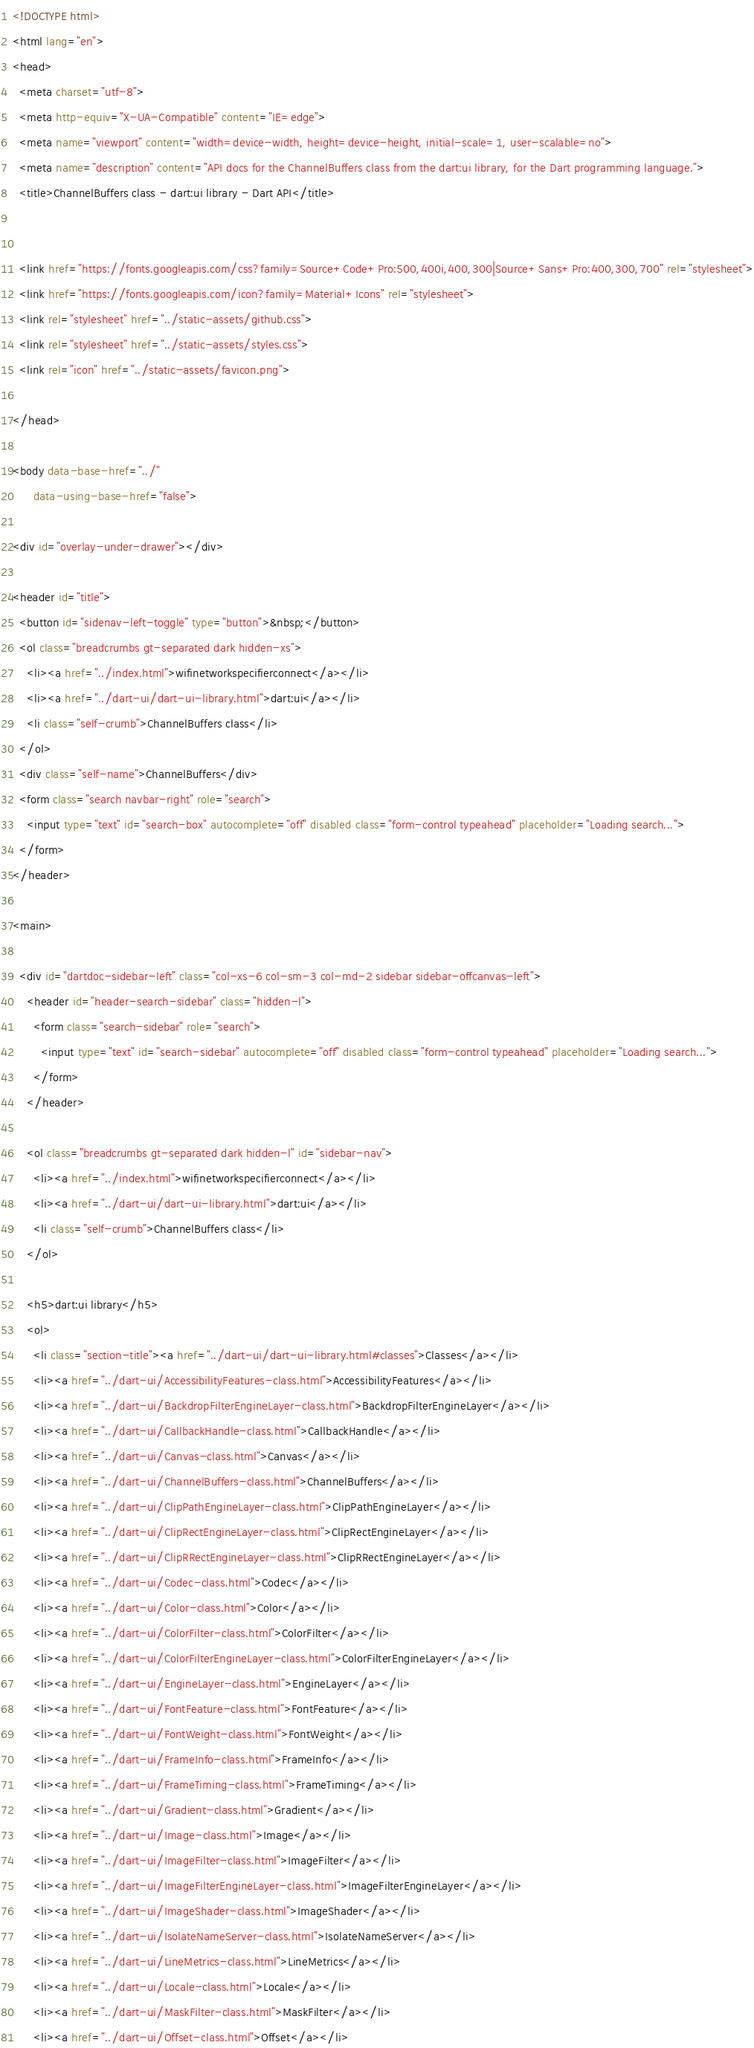Convert code to text. <code><loc_0><loc_0><loc_500><loc_500><_HTML_><!DOCTYPE html>
<html lang="en">
<head>
  <meta charset="utf-8">
  <meta http-equiv="X-UA-Compatible" content="IE=edge">
  <meta name="viewport" content="width=device-width, height=device-height, initial-scale=1, user-scalable=no">
  <meta name="description" content="API docs for the ChannelBuffers class from the dart:ui library, for the Dart programming language.">
  <title>ChannelBuffers class - dart:ui library - Dart API</title>

  
  <link href="https://fonts.googleapis.com/css?family=Source+Code+Pro:500,400i,400,300|Source+Sans+Pro:400,300,700" rel="stylesheet">
  <link href="https://fonts.googleapis.com/icon?family=Material+Icons" rel="stylesheet">
  <link rel="stylesheet" href="../static-assets/github.css">
  <link rel="stylesheet" href="../static-assets/styles.css">
  <link rel="icon" href="../static-assets/favicon.png">

</head>

<body data-base-href="../"
      data-using-base-href="false">

<div id="overlay-under-drawer"></div>

<header id="title">
  <button id="sidenav-left-toggle" type="button">&nbsp;</button>
  <ol class="breadcrumbs gt-separated dark hidden-xs">
    <li><a href="../index.html">wifinetworkspecifierconnect</a></li>
    <li><a href="../dart-ui/dart-ui-library.html">dart:ui</a></li>
    <li class="self-crumb">ChannelBuffers class</li>
  </ol>
  <div class="self-name">ChannelBuffers</div>
  <form class="search navbar-right" role="search">
    <input type="text" id="search-box" autocomplete="off" disabled class="form-control typeahead" placeholder="Loading search...">
  </form>
</header>

<main>

  <div id="dartdoc-sidebar-left" class="col-xs-6 col-sm-3 col-md-2 sidebar sidebar-offcanvas-left">
    <header id="header-search-sidebar" class="hidden-l">
      <form class="search-sidebar" role="search">
        <input type="text" id="search-sidebar" autocomplete="off" disabled class="form-control typeahead" placeholder="Loading search...">
      </form>
    </header>
    
    <ol class="breadcrumbs gt-separated dark hidden-l" id="sidebar-nav">
      <li><a href="../index.html">wifinetworkspecifierconnect</a></li>
      <li><a href="../dart-ui/dart-ui-library.html">dart:ui</a></li>
      <li class="self-crumb">ChannelBuffers class</li>
    </ol>
    
    <h5>dart:ui library</h5>
    <ol>
      <li class="section-title"><a href="../dart-ui/dart-ui-library.html#classes">Classes</a></li>
      <li><a href="../dart-ui/AccessibilityFeatures-class.html">AccessibilityFeatures</a></li>
      <li><a href="../dart-ui/BackdropFilterEngineLayer-class.html">BackdropFilterEngineLayer</a></li>
      <li><a href="../dart-ui/CallbackHandle-class.html">CallbackHandle</a></li>
      <li><a href="../dart-ui/Canvas-class.html">Canvas</a></li>
      <li><a href="../dart-ui/ChannelBuffers-class.html">ChannelBuffers</a></li>
      <li><a href="../dart-ui/ClipPathEngineLayer-class.html">ClipPathEngineLayer</a></li>
      <li><a href="../dart-ui/ClipRectEngineLayer-class.html">ClipRectEngineLayer</a></li>
      <li><a href="../dart-ui/ClipRRectEngineLayer-class.html">ClipRRectEngineLayer</a></li>
      <li><a href="../dart-ui/Codec-class.html">Codec</a></li>
      <li><a href="../dart-ui/Color-class.html">Color</a></li>
      <li><a href="../dart-ui/ColorFilter-class.html">ColorFilter</a></li>
      <li><a href="../dart-ui/ColorFilterEngineLayer-class.html">ColorFilterEngineLayer</a></li>
      <li><a href="../dart-ui/EngineLayer-class.html">EngineLayer</a></li>
      <li><a href="../dart-ui/FontFeature-class.html">FontFeature</a></li>
      <li><a href="../dart-ui/FontWeight-class.html">FontWeight</a></li>
      <li><a href="../dart-ui/FrameInfo-class.html">FrameInfo</a></li>
      <li><a href="../dart-ui/FrameTiming-class.html">FrameTiming</a></li>
      <li><a href="../dart-ui/Gradient-class.html">Gradient</a></li>
      <li><a href="../dart-ui/Image-class.html">Image</a></li>
      <li><a href="../dart-ui/ImageFilter-class.html">ImageFilter</a></li>
      <li><a href="../dart-ui/ImageFilterEngineLayer-class.html">ImageFilterEngineLayer</a></li>
      <li><a href="../dart-ui/ImageShader-class.html">ImageShader</a></li>
      <li><a href="../dart-ui/IsolateNameServer-class.html">IsolateNameServer</a></li>
      <li><a href="../dart-ui/LineMetrics-class.html">LineMetrics</a></li>
      <li><a href="../dart-ui/Locale-class.html">Locale</a></li>
      <li><a href="../dart-ui/MaskFilter-class.html">MaskFilter</a></li>
      <li><a href="../dart-ui/Offset-class.html">Offset</a></li></code> 